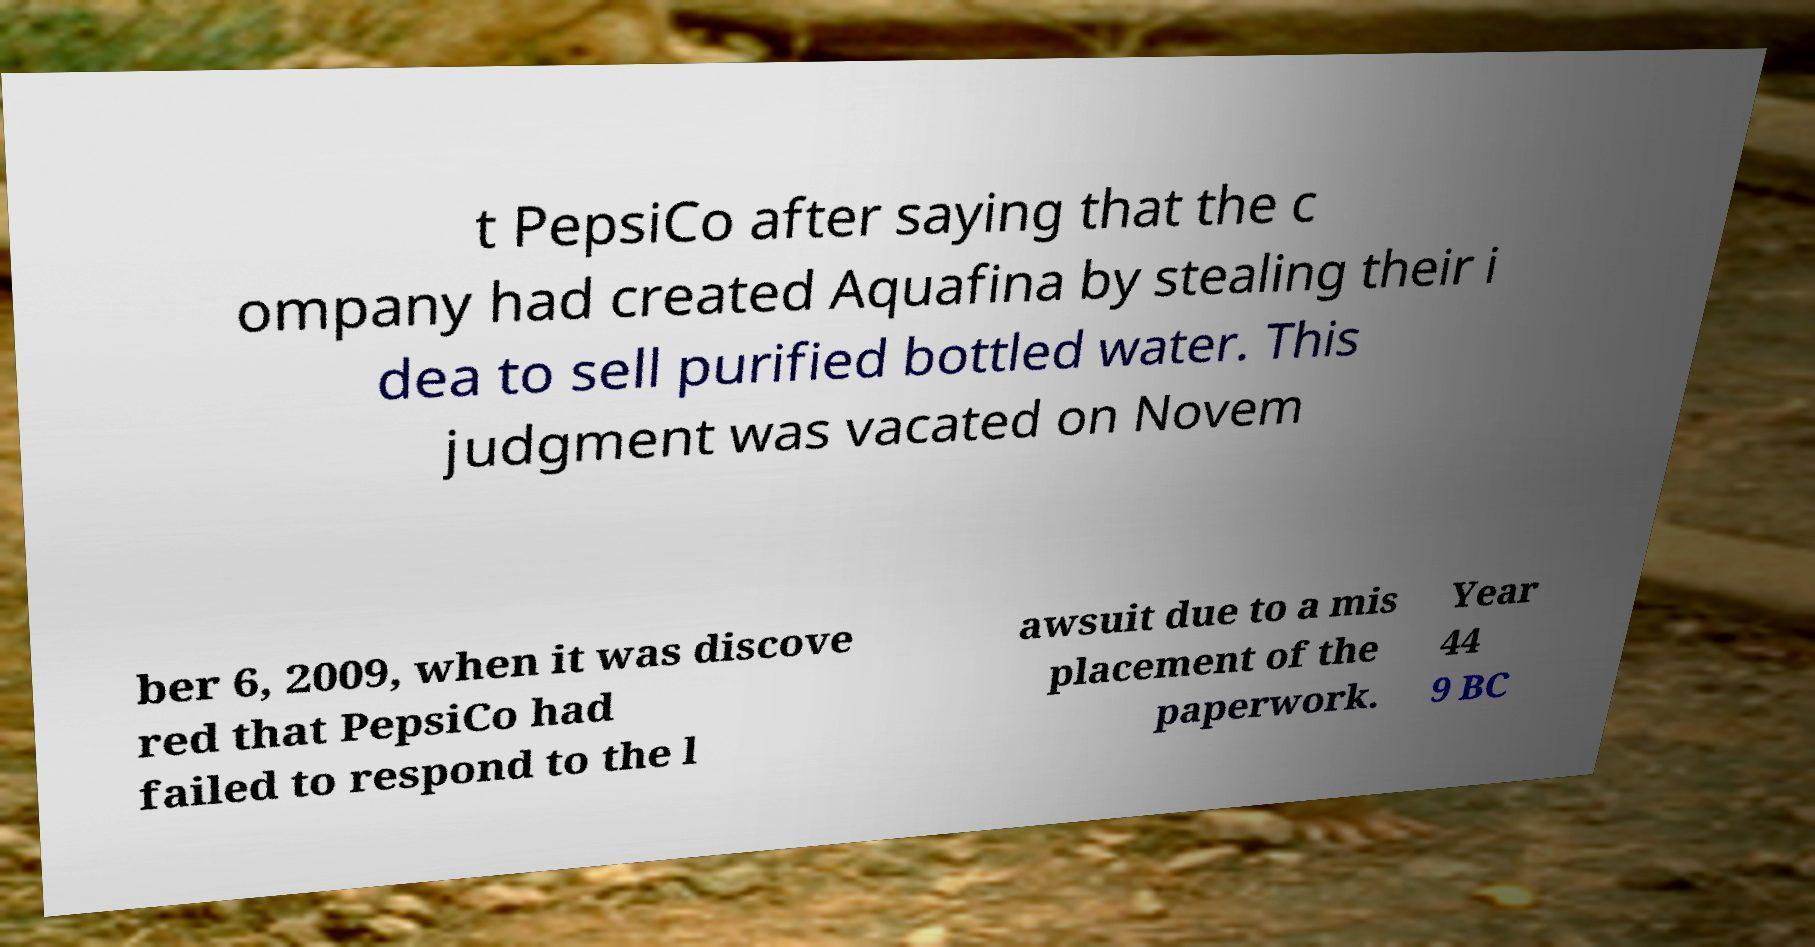For documentation purposes, I need the text within this image transcribed. Could you provide that? t PepsiCo after saying that the c ompany had created Aquafina by stealing their i dea to sell purified bottled water. This judgment was vacated on Novem ber 6, 2009, when it was discove red that PepsiCo had failed to respond to the l awsuit due to a mis placement of the paperwork. Year 44 9 BC 